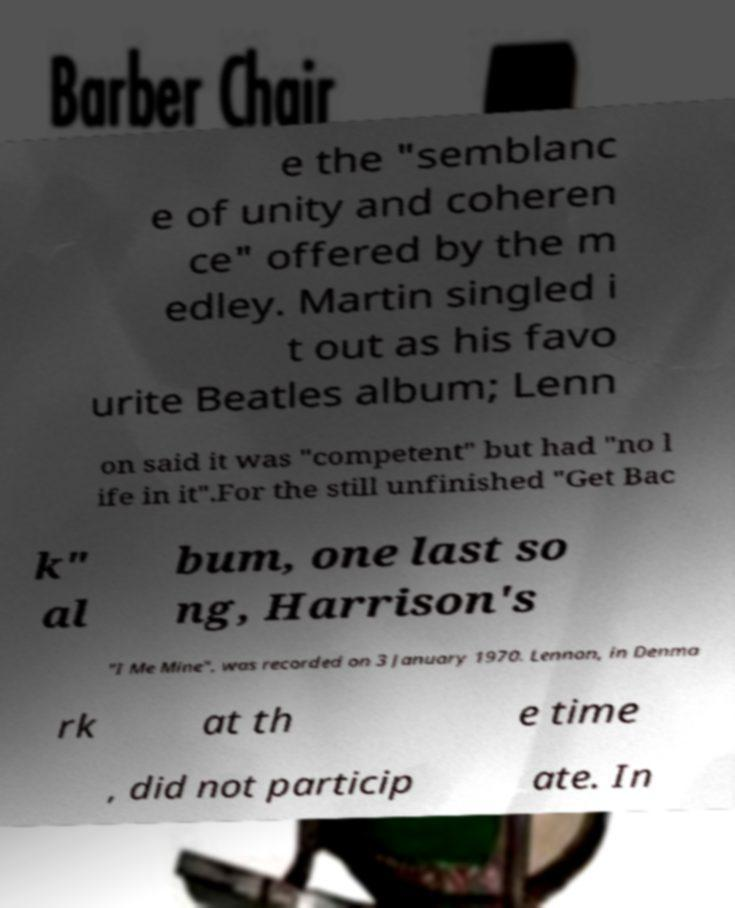What messages or text are displayed in this image? I need them in a readable, typed format. e the "semblanc e of unity and coheren ce" offered by the m edley. Martin singled i t out as his favo urite Beatles album; Lenn on said it was "competent" but had "no l ife in it".For the still unfinished "Get Bac k" al bum, one last so ng, Harrison's "I Me Mine", was recorded on 3 January 1970. Lennon, in Denma rk at th e time , did not particip ate. In 